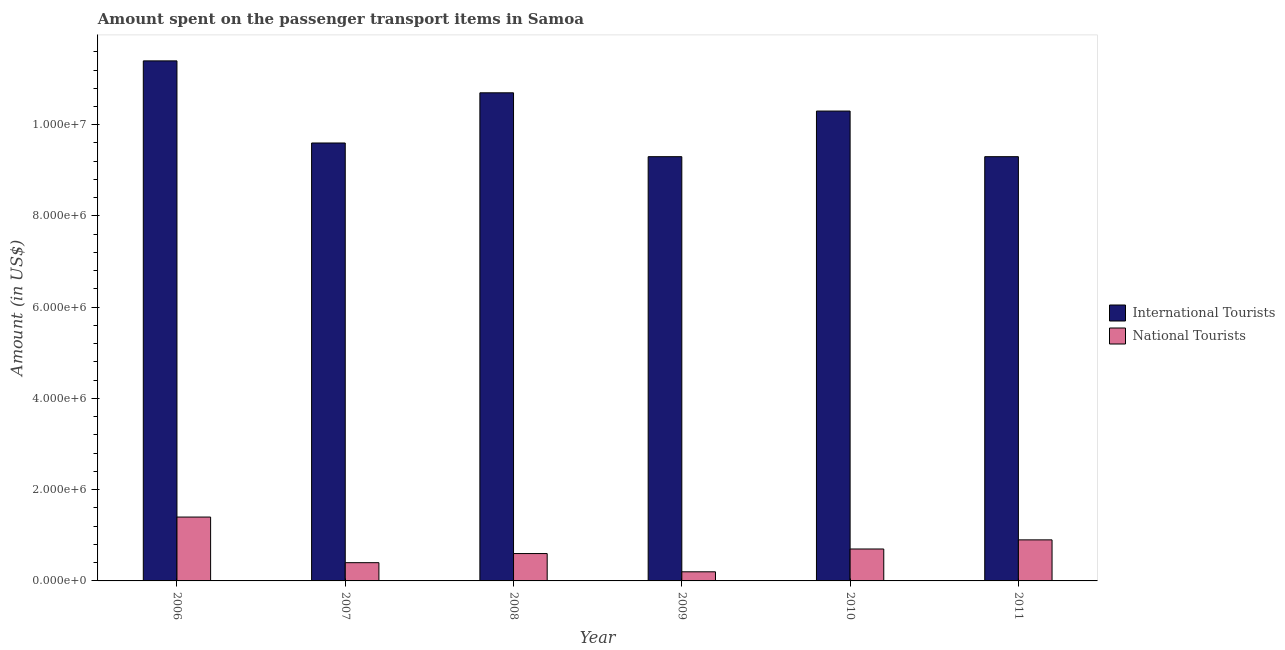How many groups of bars are there?
Your answer should be very brief. 6. Are the number of bars on each tick of the X-axis equal?
Offer a terse response. Yes. What is the amount spent on transport items of international tourists in 2010?
Give a very brief answer. 1.03e+07. Across all years, what is the maximum amount spent on transport items of international tourists?
Ensure brevity in your answer.  1.14e+07. Across all years, what is the minimum amount spent on transport items of international tourists?
Offer a very short reply. 9.30e+06. In which year was the amount spent on transport items of national tourists minimum?
Your answer should be very brief. 2009. What is the total amount spent on transport items of national tourists in the graph?
Give a very brief answer. 4.20e+06. What is the difference between the amount spent on transport items of international tourists in 2006 and that in 2011?
Your response must be concise. 2.10e+06. What is the difference between the amount spent on transport items of national tourists in 2006 and the amount spent on transport items of international tourists in 2009?
Provide a short and direct response. 1.20e+06. What is the average amount spent on transport items of national tourists per year?
Provide a short and direct response. 7.00e+05. What is the ratio of the amount spent on transport items of national tourists in 2008 to that in 2009?
Ensure brevity in your answer.  3. Is the amount spent on transport items of national tourists in 2008 less than that in 2009?
Provide a succinct answer. No. What is the difference between the highest and the lowest amount spent on transport items of international tourists?
Offer a terse response. 2.10e+06. In how many years, is the amount spent on transport items of national tourists greater than the average amount spent on transport items of national tourists taken over all years?
Ensure brevity in your answer.  2. What does the 1st bar from the left in 2011 represents?
Provide a short and direct response. International Tourists. What does the 2nd bar from the right in 2011 represents?
Give a very brief answer. International Tourists. How many bars are there?
Keep it short and to the point. 12. What is the difference between two consecutive major ticks on the Y-axis?
Your answer should be very brief. 2.00e+06. Where does the legend appear in the graph?
Offer a terse response. Center right. How are the legend labels stacked?
Provide a short and direct response. Vertical. What is the title of the graph?
Offer a terse response. Amount spent on the passenger transport items in Samoa. Does "Non-solid fuel" appear as one of the legend labels in the graph?
Your answer should be compact. No. What is the label or title of the X-axis?
Make the answer very short. Year. What is the Amount (in US$) in International Tourists in 2006?
Give a very brief answer. 1.14e+07. What is the Amount (in US$) in National Tourists in 2006?
Your response must be concise. 1.40e+06. What is the Amount (in US$) in International Tourists in 2007?
Give a very brief answer. 9.60e+06. What is the Amount (in US$) in International Tourists in 2008?
Your answer should be compact. 1.07e+07. What is the Amount (in US$) in International Tourists in 2009?
Make the answer very short. 9.30e+06. What is the Amount (in US$) in National Tourists in 2009?
Your answer should be very brief. 2.00e+05. What is the Amount (in US$) of International Tourists in 2010?
Offer a terse response. 1.03e+07. What is the Amount (in US$) of National Tourists in 2010?
Provide a short and direct response. 7.00e+05. What is the Amount (in US$) of International Tourists in 2011?
Ensure brevity in your answer.  9.30e+06. Across all years, what is the maximum Amount (in US$) of International Tourists?
Give a very brief answer. 1.14e+07. Across all years, what is the maximum Amount (in US$) in National Tourists?
Your answer should be compact. 1.40e+06. Across all years, what is the minimum Amount (in US$) in International Tourists?
Your response must be concise. 9.30e+06. Across all years, what is the minimum Amount (in US$) in National Tourists?
Ensure brevity in your answer.  2.00e+05. What is the total Amount (in US$) of International Tourists in the graph?
Provide a succinct answer. 6.06e+07. What is the total Amount (in US$) in National Tourists in the graph?
Offer a very short reply. 4.20e+06. What is the difference between the Amount (in US$) of International Tourists in 2006 and that in 2007?
Offer a very short reply. 1.80e+06. What is the difference between the Amount (in US$) of National Tourists in 2006 and that in 2008?
Give a very brief answer. 8.00e+05. What is the difference between the Amount (in US$) of International Tourists in 2006 and that in 2009?
Ensure brevity in your answer.  2.10e+06. What is the difference between the Amount (in US$) in National Tourists in 2006 and that in 2009?
Offer a terse response. 1.20e+06. What is the difference between the Amount (in US$) of International Tourists in 2006 and that in 2010?
Offer a terse response. 1.10e+06. What is the difference between the Amount (in US$) in International Tourists in 2006 and that in 2011?
Ensure brevity in your answer.  2.10e+06. What is the difference between the Amount (in US$) in National Tourists in 2006 and that in 2011?
Offer a terse response. 5.00e+05. What is the difference between the Amount (in US$) in International Tourists in 2007 and that in 2008?
Your response must be concise. -1.10e+06. What is the difference between the Amount (in US$) of National Tourists in 2007 and that in 2008?
Your answer should be very brief. -2.00e+05. What is the difference between the Amount (in US$) of International Tourists in 2007 and that in 2010?
Provide a short and direct response. -7.00e+05. What is the difference between the Amount (in US$) in National Tourists in 2007 and that in 2010?
Your response must be concise. -3.00e+05. What is the difference between the Amount (in US$) of International Tourists in 2007 and that in 2011?
Your answer should be very brief. 3.00e+05. What is the difference between the Amount (in US$) in National Tourists in 2007 and that in 2011?
Your answer should be compact. -5.00e+05. What is the difference between the Amount (in US$) in International Tourists in 2008 and that in 2009?
Offer a terse response. 1.40e+06. What is the difference between the Amount (in US$) in National Tourists in 2008 and that in 2009?
Your answer should be very brief. 4.00e+05. What is the difference between the Amount (in US$) of International Tourists in 2008 and that in 2010?
Make the answer very short. 4.00e+05. What is the difference between the Amount (in US$) in National Tourists in 2008 and that in 2010?
Offer a terse response. -1.00e+05. What is the difference between the Amount (in US$) in International Tourists in 2008 and that in 2011?
Give a very brief answer. 1.40e+06. What is the difference between the Amount (in US$) of National Tourists in 2008 and that in 2011?
Provide a short and direct response. -3.00e+05. What is the difference between the Amount (in US$) of National Tourists in 2009 and that in 2010?
Your answer should be very brief. -5.00e+05. What is the difference between the Amount (in US$) in National Tourists in 2009 and that in 2011?
Keep it short and to the point. -7.00e+05. What is the difference between the Amount (in US$) in National Tourists in 2010 and that in 2011?
Ensure brevity in your answer.  -2.00e+05. What is the difference between the Amount (in US$) of International Tourists in 2006 and the Amount (in US$) of National Tourists in 2007?
Ensure brevity in your answer.  1.10e+07. What is the difference between the Amount (in US$) of International Tourists in 2006 and the Amount (in US$) of National Tourists in 2008?
Give a very brief answer. 1.08e+07. What is the difference between the Amount (in US$) in International Tourists in 2006 and the Amount (in US$) in National Tourists in 2009?
Offer a very short reply. 1.12e+07. What is the difference between the Amount (in US$) in International Tourists in 2006 and the Amount (in US$) in National Tourists in 2010?
Your answer should be very brief. 1.07e+07. What is the difference between the Amount (in US$) of International Tourists in 2006 and the Amount (in US$) of National Tourists in 2011?
Your answer should be very brief. 1.05e+07. What is the difference between the Amount (in US$) of International Tourists in 2007 and the Amount (in US$) of National Tourists in 2008?
Ensure brevity in your answer.  9.00e+06. What is the difference between the Amount (in US$) in International Tourists in 2007 and the Amount (in US$) in National Tourists in 2009?
Ensure brevity in your answer.  9.40e+06. What is the difference between the Amount (in US$) in International Tourists in 2007 and the Amount (in US$) in National Tourists in 2010?
Keep it short and to the point. 8.90e+06. What is the difference between the Amount (in US$) in International Tourists in 2007 and the Amount (in US$) in National Tourists in 2011?
Provide a short and direct response. 8.70e+06. What is the difference between the Amount (in US$) of International Tourists in 2008 and the Amount (in US$) of National Tourists in 2009?
Keep it short and to the point. 1.05e+07. What is the difference between the Amount (in US$) in International Tourists in 2008 and the Amount (in US$) in National Tourists in 2011?
Make the answer very short. 9.80e+06. What is the difference between the Amount (in US$) in International Tourists in 2009 and the Amount (in US$) in National Tourists in 2010?
Ensure brevity in your answer.  8.60e+06. What is the difference between the Amount (in US$) of International Tourists in 2009 and the Amount (in US$) of National Tourists in 2011?
Provide a short and direct response. 8.40e+06. What is the difference between the Amount (in US$) in International Tourists in 2010 and the Amount (in US$) in National Tourists in 2011?
Offer a terse response. 9.40e+06. What is the average Amount (in US$) in International Tourists per year?
Offer a terse response. 1.01e+07. In the year 2006, what is the difference between the Amount (in US$) in International Tourists and Amount (in US$) in National Tourists?
Keep it short and to the point. 1.00e+07. In the year 2007, what is the difference between the Amount (in US$) in International Tourists and Amount (in US$) in National Tourists?
Offer a very short reply. 9.20e+06. In the year 2008, what is the difference between the Amount (in US$) in International Tourists and Amount (in US$) in National Tourists?
Give a very brief answer. 1.01e+07. In the year 2009, what is the difference between the Amount (in US$) of International Tourists and Amount (in US$) of National Tourists?
Offer a terse response. 9.10e+06. In the year 2010, what is the difference between the Amount (in US$) of International Tourists and Amount (in US$) of National Tourists?
Keep it short and to the point. 9.60e+06. In the year 2011, what is the difference between the Amount (in US$) in International Tourists and Amount (in US$) in National Tourists?
Provide a succinct answer. 8.40e+06. What is the ratio of the Amount (in US$) of International Tourists in 2006 to that in 2007?
Offer a terse response. 1.19. What is the ratio of the Amount (in US$) of International Tourists in 2006 to that in 2008?
Provide a short and direct response. 1.07. What is the ratio of the Amount (in US$) in National Tourists in 2006 to that in 2008?
Give a very brief answer. 2.33. What is the ratio of the Amount (in US$) of International Tourists in 2006 to that in 2009?
Your response must be concise. 1.23. What is the ratio of the Amount (in US$) of International Tourists in 2006 to that in 2010?
Make the answer very short. 1.11. What is the ratio of the Amount (in US$) of National Tourists in 2006 to that in 2010?
Provide a succinct answer. 2. What is the ratio of the Amount (in US$) of International Tourists in 2006 to that in 2011?
Provide a short and direct response. 1.23. What is the ratio of the Amount (in US$) in National Tourists in 2006 to that in 2011?
Your answer should be very brief. 1.56. What is the ratio of the Amount (in US$) of International Tourists in 2007 to that in 2008?
Offer a very short reply. 0.9. What is the ratio of the Amount (in US$) of National Tourists in 2007 to that in 2008?
Ensure brevity in your answer.  0.67. What is the ratio of the Amount (in US$) of International Tourists in 2007 to that in 2009?
Make the answer very short. 1.03. What is the ratio of the Amount (in US$) of National Tourists in 2007 to that in 2009?
Make the answer very short. 2. What is the ratio of the Amount (in US$) of International Tourists in 2007 to that in 2010?
Offer a very short reply. 0.93. What is the ratio of the Amount (in US$) of International Tourists in 2007 to that in 2011?
Ensure brevity in your answer.  1.03. What is the ratio of the Amount (in US$) of National Tourists in 2007 to that in 2011?
Your response must be concise. 0.44. What is the ratio of the Amount (in US$) in International Tourists in 2008 to that in 2009?
Your answer should be compact. 1.15. What is the ratio of the Amount (in US$) in International Tourists in 2008 to that in 2010?
Your answer should be very brief. 1.04. What is the ratio of the Amount (in US$) of International Tourists in 2008 to that in 2011?
Offer a very short reply. 1.15. What is the ratio of the Amount (in US$) of National Tourists in 2008 to that in 2011?
Your response must be concise. 0.67. What is the ratio of the Amount (in US$) in International Tourists in 2009 to that in 2010?
Your response must be concise. 0.9. What is the ratio of the Amount (in US$) in National Tourists in 2009 to that in 2010?
Provide a short and direct response. 0.29. What is the ratio of the Amount (in US$) of International Tourists in 2009 to that in 2011?
Give a very brief answer. 1. What is the ratio of the Amount (in US$) in National Tourists in 2009 to that in 2011?
Provide a succinct answer. 0.22. What is the ratio of the Amount (in US$) in International Tourists in 2010 to that in 2011?
Offer a terse response. 1.11. What is the difference between the highest and the lowest Amount (in US$) of International Tourists?
Provide a short and direct response. 2.10e+06. What is the difference between the highest and the lowest Amount (in US$) of National Tourists?
Provide a succinct answer. 1.20e+06. 